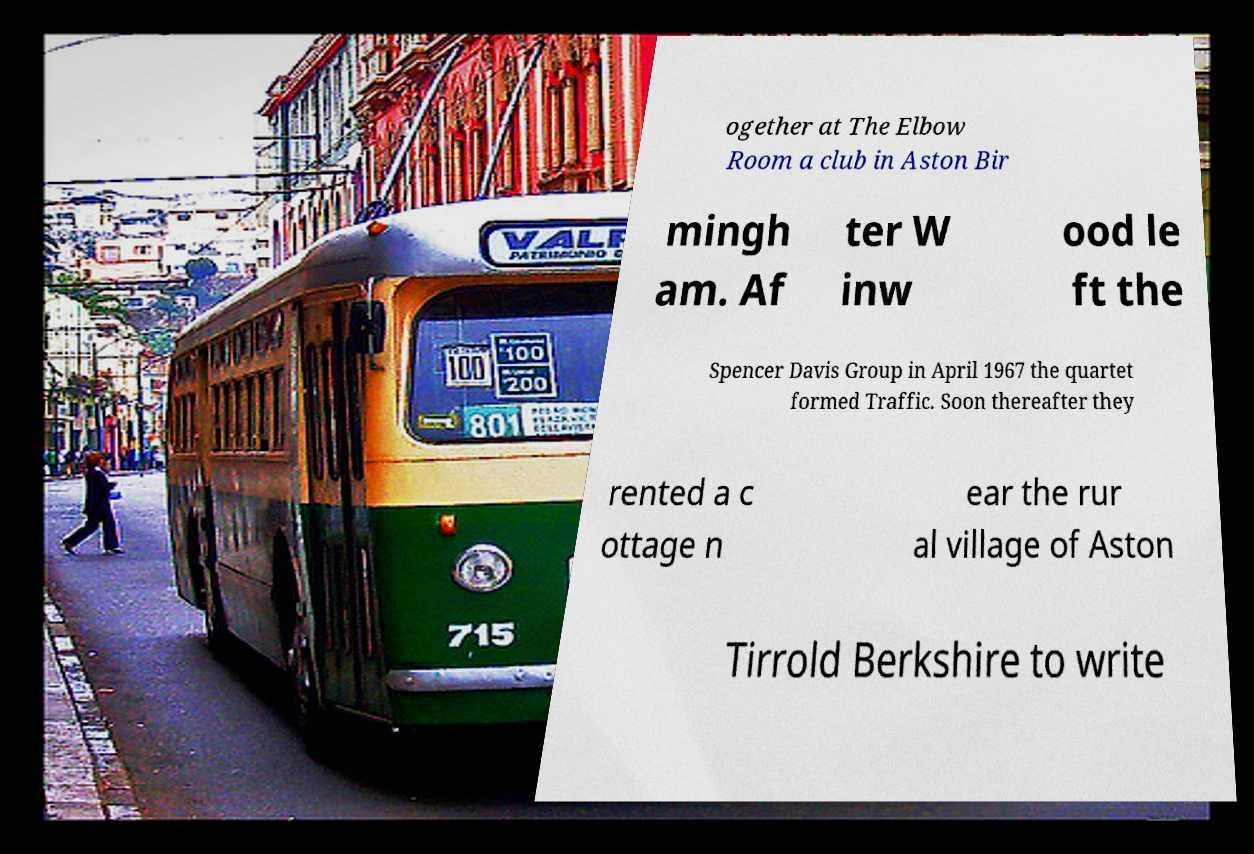Please read and relay the text visible in this image. What does it say? ogether at The Elbow Room a club in Aston Bir mingh am. Af ter W inw ood le ft the Spencer Davis Group in April 1967 the quartet formed Traffic. Soon thereafter they rented a c ottage n ear the rur al village of Aston Tirrold Berkshire to write 